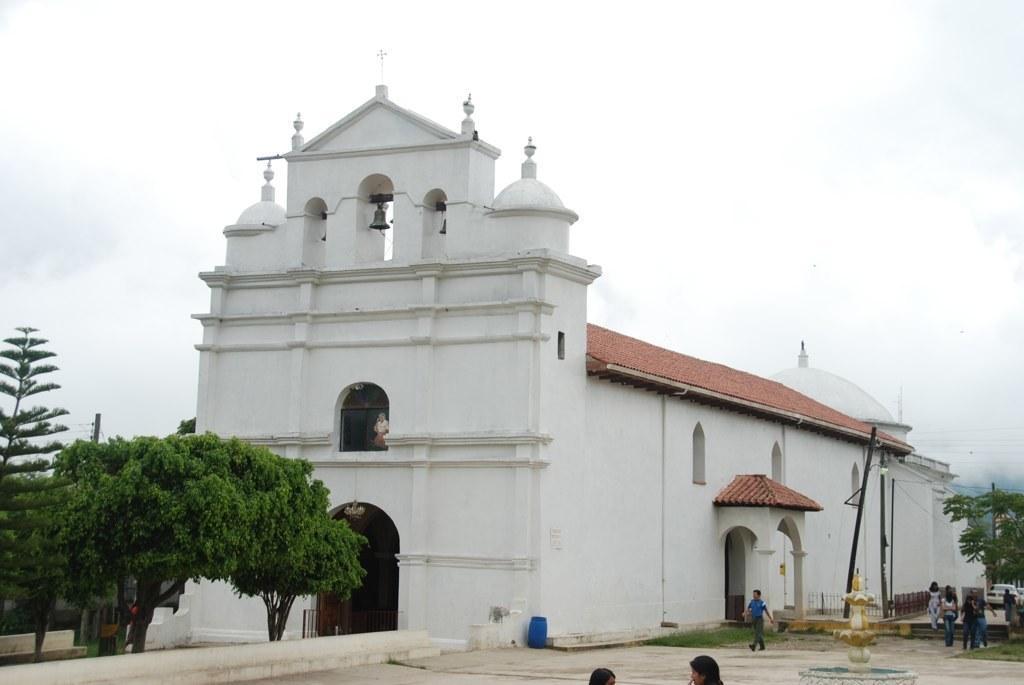Can you describe this image briefly? In this image, we can see a white color building. There are some trees and poles. We can also see a few people. We can also see the sky. 